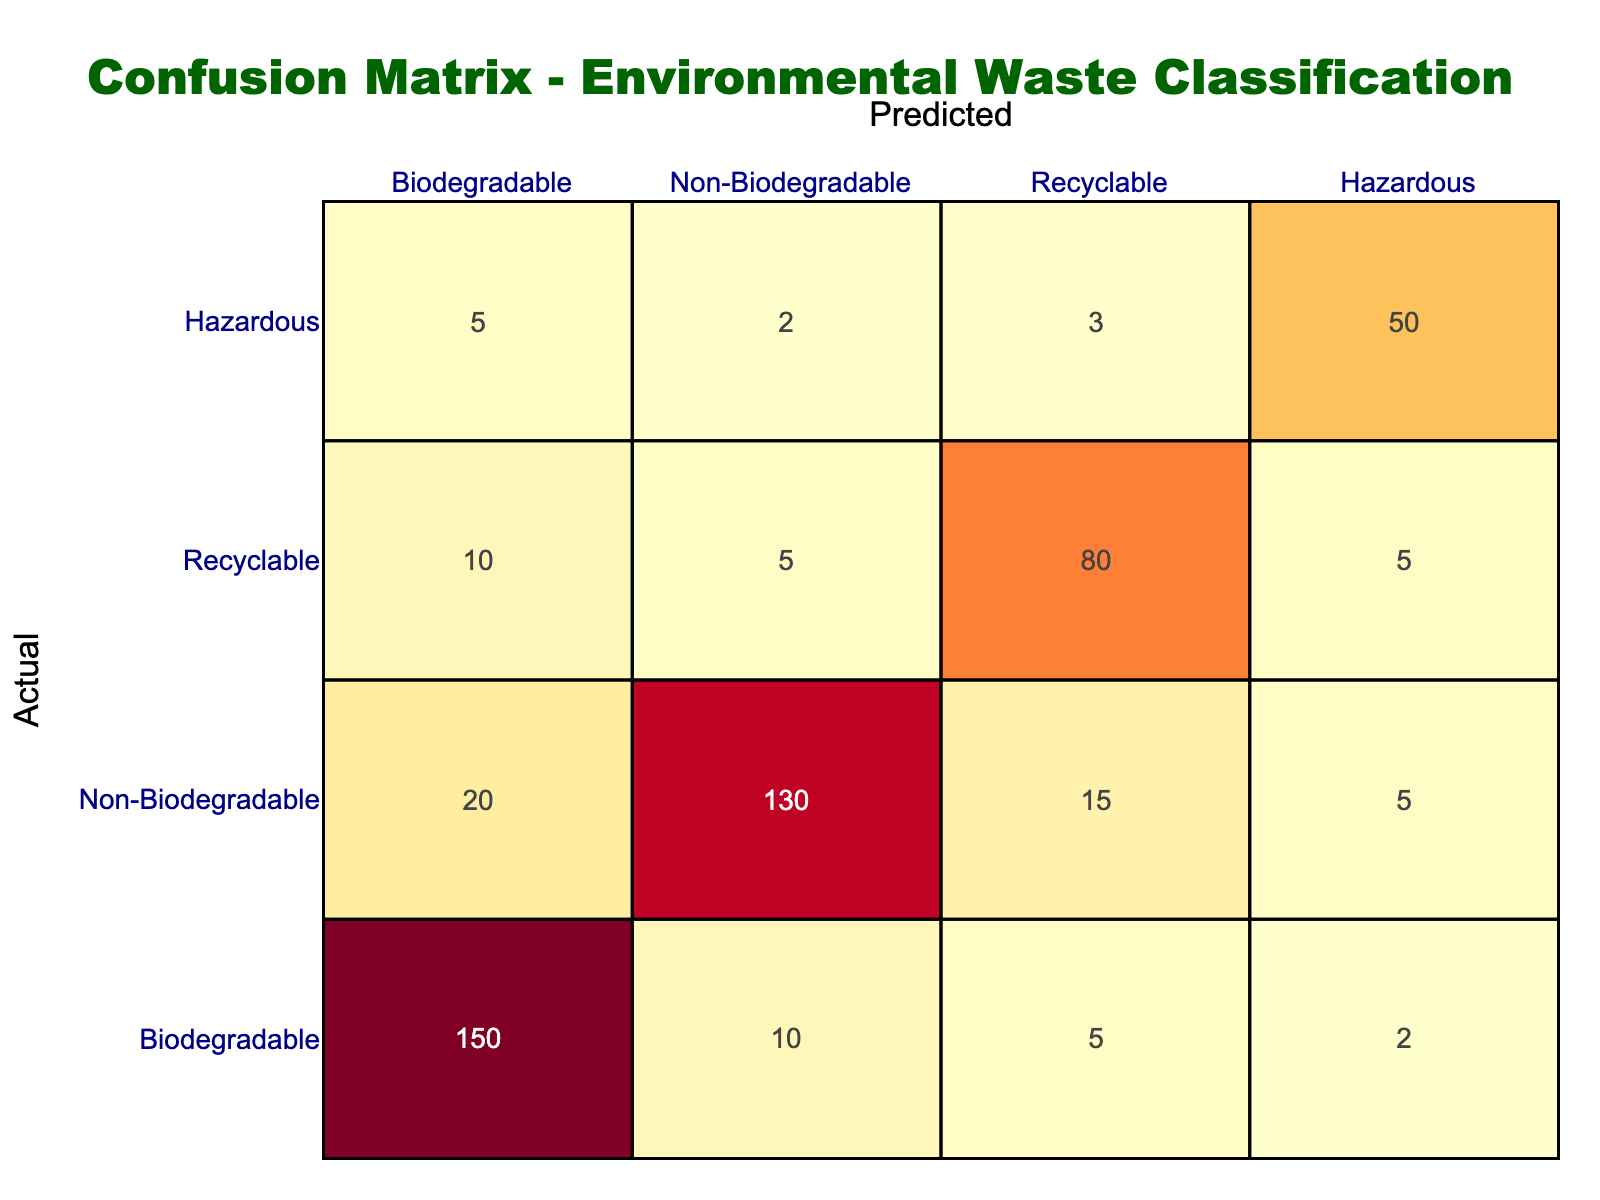What is the total number of actual biodegradable waste classified correctly? Looking at the row corresponding to "Biodegradable" in the confusion matrix, the correct classifications (True Positives) are represented by the first value, which is 150. Therefore, the total number of biodegradable waste classified correctly is 150.
Answer: 150 How many items were incorrectly classified as non-biodegradable when they were actually recyclable? In the "Recyclable" row, the column for "Non-Biodegradable" shows a value of 5. This indicates that 5 items were incorrectly classified as non-biodegradable instead of recyclable.
Answer: 5 What is the total number of hazardous waste predicted in the table? To find the total predicted hazardous waste, we look at the last column ("Hazardous") and sum all the values from each actual category, which gives us: 2 (Biodegradable) + 5 (Non-Biodegradable) + 5 (Recyclable) + 50 (Hazardous) = 62. Therefore, the total predicted hazardous waste is 62.
Answer: 62 Is it true that most of the recyclable waste was classified correctly? To evaluate this, we check the row for "Recyclable." The correctly classified recyclable waste is 80 (True Positives), while there are 10 items classified as biodegradable and 5 classified as non-biodegradable, leading to 15 incorrect classifications. Since 80 is notably higher than 15, the statement is true.
Answer: Yes What is the accuracy of the non-biodegradable classification? Accuracy is calculated by taking the number of correct predictions for non-biodegradable waste (130) and dividing it by the total predictions made for non-biodegradable waste (20 + 130 + 15 + 5 = 170). The accuracy formula gives us: 130/170 = 0.7647 or 76.47 percent.
Answer: 76.47 percent 